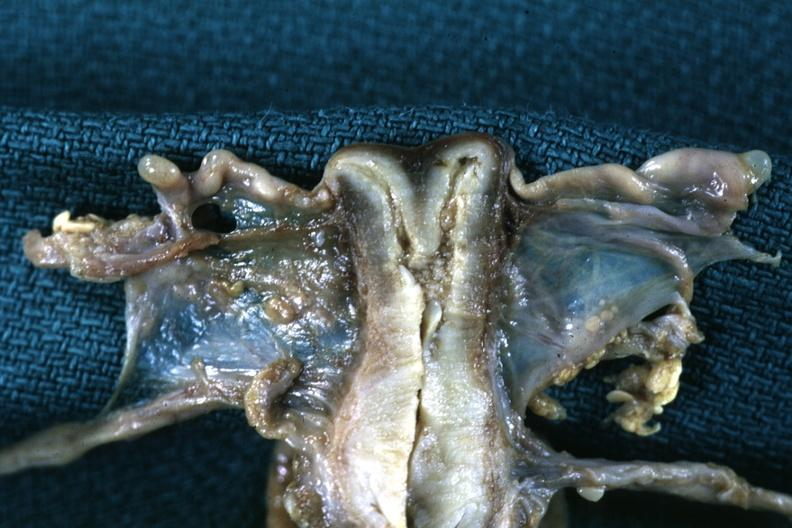where does this part belong to?
Answer the question using a single word or phrase. Female reproductive system 